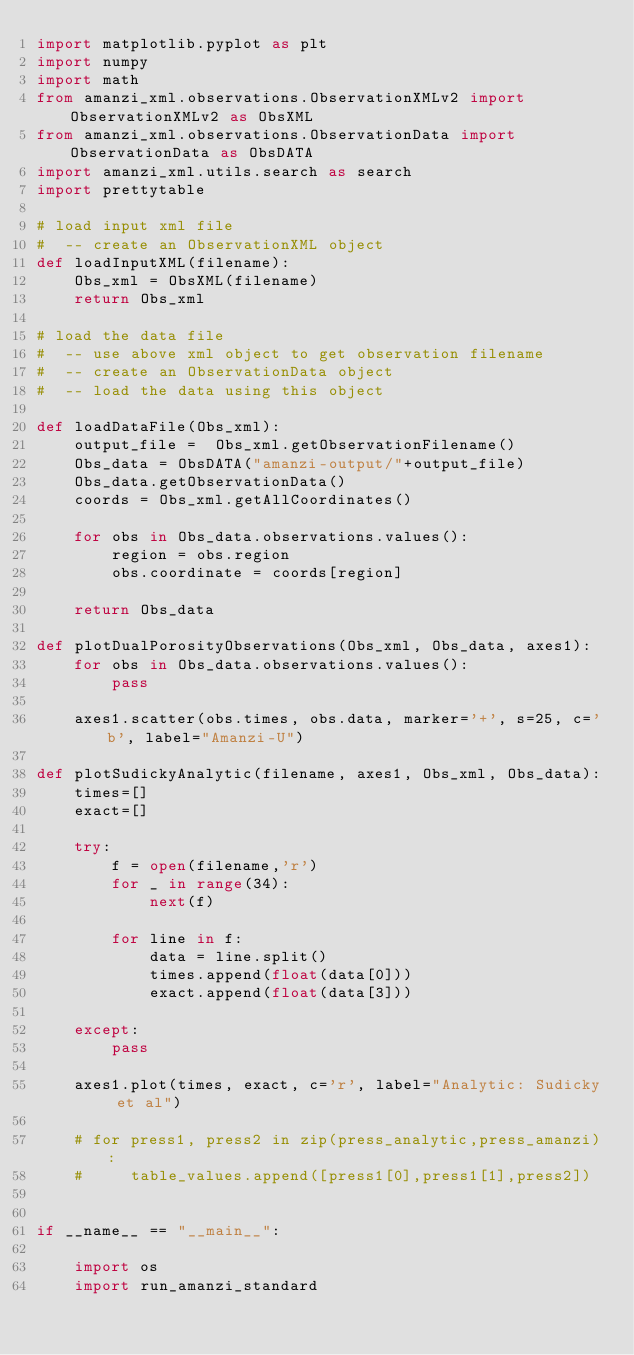Convert code to text. <code><loc_0><loc_0><loc_500><loc_500><_Python_>import matplotlib.pyplot as plt
import numpy
import math
from amanzi_xml.observations.ObservationXMLv2 import ObservationXMLv2 as ObsXML
from amanzi_xml.observations.ObservationData import ObservationData as ObsDATA
import amanzi_xml.utils.search as search
import prettytable

# load input xml file
#  -- create an ObservationXML object
def loadInputXML(filename):
    Obs_xml = ObsXML(filename)
    return Obs_xml

# load the data file
#  -- use above xml object to get observation filename
#  -- create an ObservationData object
#  -- load the data using this object

def loadDataFile(Obs_xml):
    output_file =  Obs_xml.getObservationFilename()
    Obs_data = ObsDATA("amanzi-output/"+output_file)
    Obs_data.getObservationData()
    coords = Obs_xml.getAllCoordinates()

    for obs in Obs_data.observations.values():
        region = obs.region
        obs.coordinate = coords[region]
    
    return Obs_data

def plotDualPorosityObservations(Obs_xml, Obs_data, axes1):
    for obs in Obs_data.observations.values():
        pass

    axes1.scatter(obs.times, obs.data, marker='+', s=25, c='b', label="Amanzi-U")

def plotSudickyAnalytic(filename, axes1, Obs_xml, Obs_data):
    times=[]
    exact=[]

    try:
        f = open(filename,'r')
        for _ in range(34):
            next(f)

        for line in f:
            data = line.split()
            times.append(float(data[0]))
            exact.append(float(data[3]))

    except:
        pass

    axes1.plot(times, exact, c='r', label="Analytic: Sudicky et al")

    # for press1, press2 in zip(press_analytic,press_amanzi):
    #     table_values.append([press1[0],press1[1],press2])
        

if __name__ == "__main__":

    import os
    import run_amanzi_standard
</code> 